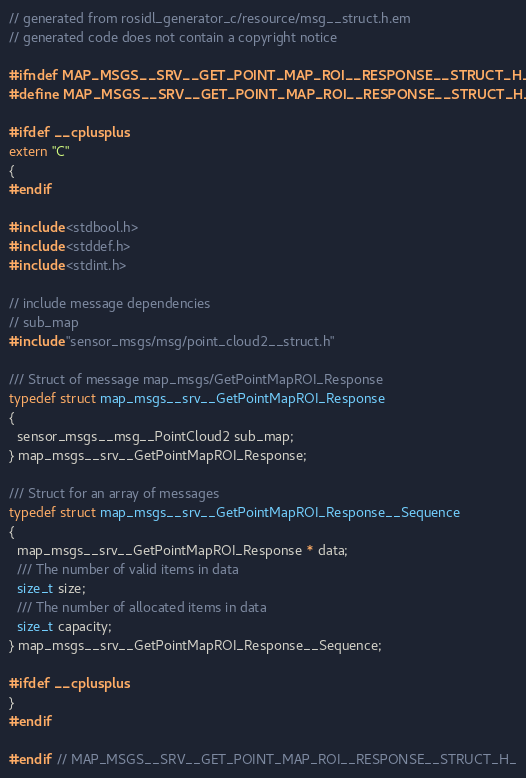Convert code to text. <code><loc_0><loc_0><loc_500><loc_500><_C_>// generated from rosidl_generator_c/resource/msg__struct.h.em
// generated code does not contain a copyright notice

#ifndef MAP_MSGS__SRV__GET_POINT_MAP_ROI__RESPONSE__STRUCT_H_
#define MAP_MSGS__SRV__GET_POINT_MAP_ROI__RESPONSE__STRUCT_H_

#ifdef __cplusplus
extern "C"
{
#endif

#include <stdbool.h>
#include <stddef.h>
#include <stdint.h>

// include message dependencies
// sub_map
#include "sensor_msgs/msg/point_cloud2__struct.h"

/// Struct of message map_msgs/GetPointMapROI_Response
typedef struct map_msgs__srv__GetPointMapROI_Response
{
  sensor_msgs__msg__PointCloud2 sub_map;
} map_msgs__srv__GetPointMapROI_Response;

/// Struct for an array of messages
typedef struct map_msgs__srv__GetPointMapROI_Response__Sequence
{
  map_msgs__srv__GetPointMapROI_Response * data;
  /// The number of valid items in data
  size_t size;
  /// The number of allocated items in data
  size_t capacity;
} map_msgs__srv__GetPointMapROI_Response__Sequence;

#ifdef __cplusplus
}
#endif

#endif  // MAP_MSGS__SRV__GET_POINT_MAP_ROI__RESPONSE__STRUCT_H_
</code> 